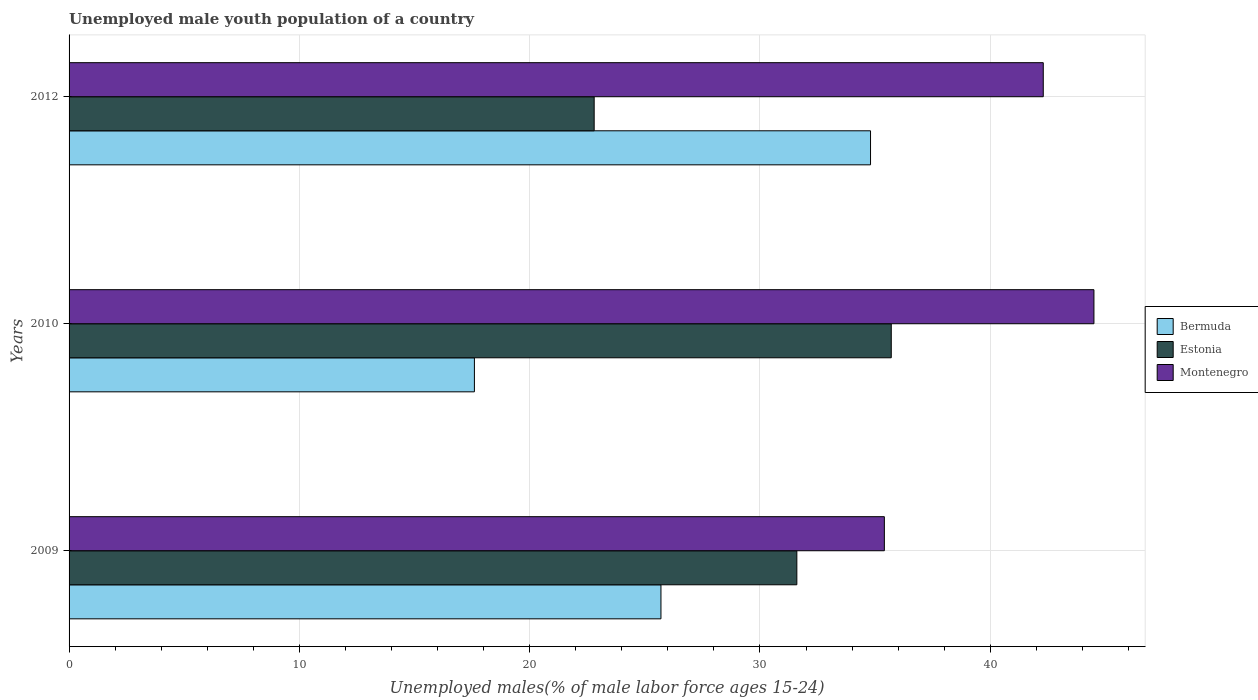How many different coloured bars are there?
Your answer should be very brief. 3. How many groups of bars are there?
Your response must be concise. 3. Are the number of bars per tick equal to the number of legend labels?
Make the answer very short. Yes. How many bars are there on the 2nd tick from the bottom?
Provide a short and direct response. 3. In how many cases, is the number of bars for a given year not equal to the number of legend labels?
Ensure brevity in your answer.  0. What is the percentage of unemployed male youth population in Montenegro in 2010?
Offer a terse response. 44.5. Across all years, what is the maximum percentage of unemployed male youth population in Estonia?
Provide a succinct answer. 35.7. Across all years, what is the minimum percentage of unemployed male youth population in Estonia?
Your response must be concise. 22.8. What is the total percentage of unemployed male youth population in Montenegro in the graph?
Make the answer very short. 122.2. What is the difference between the percentage of unemployed male youth population in Estonia in 2009 and that in 2010?
Keep it short and to the point. -4.1. What is the difference between the percentage of unemployed male youth population in Bermuda in 2010 and the percentage of unemployed male youth population in Estonia in 2009?
Your response must be concise. -14. What is the average percentage of unemployed male youth population in Estonia per year?
Your answer should be very brief. 30.03. In the year 2010, what is the difference between the percentage of unemployed male youth population in Bermuda and percentage of unemployed male youth population in Estonia?
Make the answer very short. -18.1. In how many years, is the percentage of unemployed male youth population in Estonia greater than 20 %?
Your answer should be compact. 3. What is the ratio of the percentage of unemployed male youth population in Montenegro in 2009 to that in 2010?
Your answer should be compact. 0.8. What is the difference between the highest and the second highest percentage of unemployed male youth population in Montenegro?
Make the answer very short. 2.2. What is the difference between the highest and the lowest percentage of unemployed male youth population in Estonia?
Provide a short and direct response. 12.9. In how many years, is the percentage of unemployed male youth population in Bermuda greater than the average percentage of unemployed male youth population in Bermuda taken over all years?
Your response must be concise. 1. What does the 3rd bar from the top in 2009 represents?
Your answer should be very brief. Bermuda. What does the 3rd bar from the bottom in 2012 represents?
Your answer should be very brief. Montenegro. Is it the case that in every year, the sum of the percentage of unemployed male youth population in Montenegro and percentage of unemployed male youth population in Estonia is greater than the percentage of unemployed male youth population in Bermuda?
Provide a short and direct response. Yes. Are all the bars in the graph horizontal?
Provide a succinct answer. Yes. How many years are there in the graph?
Your response must be concise. 3. What is the difference between two consecutive major ticks on the X-axis?
Keep it short and to the point. 10. Are the values on the major ticks of X-axis written in scientific E-notation?
Provide a short and direct response. No. Does the graph contain grids?
Offer a very short reply. Yes. How many legend labels are there?
Your answer should be compact. 3. What is the title of the graph?
Give a very brief answer. Unemployed male youth population of a country. Does "Niger" appear as one of the legend labels in the graph?
Your answer should be compact. No. What is the label or title of the X-axis?
Offer a terse response. Unemployed males(% of male labor force ages 15-24). What is the label or title of the Y-axis?
Provide a short and direct response. Years. What is the Unemployed males(% of male labor force ages 15-24) in Bermuda in 2009?
Your answer should be very brief. 25.7. What is the Unemployed males(% of male labor force ages 15-24) in Estonia in 2009?
Give a very brief answer. 31.6. What is the Unemployed males(% of male labor force ages 15-24) in Montenegro in 2009?
Offer a very short reply. 35.4. What is the Unemployed males(% of male labor force ages 15-24) in Bermuda in 2010?
Your response must be concise. 17.6. What is the Unemployed males(% of male labor force ages 15-24) in Estonia in 2010?
Offer a very short reply. 35.7. What is the Unemployed males(% of male labor force ages 15-24) of Montenegro in 2010?
Provide a succinct answer. 44.5. What is the Unemployed males(% of male labor force ages 15-24) of Bermuda in 2012?
Offer a very short reply. 34.8. What is the Unemployed males(% of male labor force ages 15-24) of Estonia in 2012?
Provide a short and direct response. 22.8. What is the Unemployed males(% of male labor force ages 15-24) of Montenegro in 2012?
Offer a terse response. 42.3. Across all years, what is the maximum Unemployed males(% of male labor force ages 15-24) of Bermuda?
Provide a short and direct response. 34.8. Across all years, what is the maximum Unemployed males(% of male labor force ages 15-24) of Estonia?
Ensure brevity in your answer.  35.7. Across all years, what is the maximum Unemployed males(% of male labor force ages 15-24) of Montenegro?
Ensure brevity in your answer.  44.5. Across all years, what is the minimum Unemployed males(% of male labor force ages 15-24) of Bermuda?
Provide a short and direct response. 17.6. Across all years, what is the minimum Unemployed males(% of male labor force ages 15-24) of Estonia?
Your answer should be compact. 22.8. Across all years, what is the minimum Unemployed males(% of male labor force ages 15-24) in Montenegro?
Make the answer very short. 35.4. What is the total Unemployed males(% of male labor force ages 15-24) of Bermuda in the graph?
Provide a succinct answer. 78.1. What is the total Unemployed males(% of male labor force ages 15-24) in Estonia in the graph?
Keep it short and to the point. 90.1. What is the total Unemployed males(% of male labor force ages 15-24) of Montenegro in the graph?
Give a very brief answer. 122.2. What is the difference between the Unemployed males(% of male labor force ages 15-24) in Bermuda in 2009 and that in 2010?
Keep it short and to the point. 8.1. What is the difference between the Unemployed males(% of male labor force ages 15-24) of Estonia in 2009 and that in 2012?
Provide a short and direct response. 8.8. What is the difference between the Unemployed males(% of male labor force ages 15-24) of Bermuda in 2010 and that in 2012?
Provide a short and direct response. -17.2. What is the difference between the Unemployed males(% of male labor force ages 15-24) of Montenegro in 2010 and that in 2012?
Your response must be concise. 2.2. What is the difference between the Unemployed males(% of male labor force ages 15-24) of Bermuda in 2009 and the Unemployed males(% of male labor force ages 15-24) of Montenegro in 2010?
Give a very brief answer. -18.8. What is the difference between the Unemployed males(% of male labor force ages 15-24) of Bermuda in 2009 and the Unemployed males(% of male labor force ages 15-24) of Estonia in 2012?
Give a very brief answer. 2.9. What is the difference between the Unemployed males(% of male labor force ages 15-24) in Bermuda in 2009 and the Unemployed males(% of male labor force ages 15-24) in Montenegro in 2012?
Keep it short and to the point. -16.6. What is the difference between the Unemployed males(% of male labor force ages 15-24) of Bermuda in 2010 and the Unemployed males(% of male labor force ages 15-24) of Montenegro in 2012?
Offer a very short reply. -24.7. What is the difference between the Unemployed males(% of male labor force ages 15-24) in Estonia in 2010 and the Unemployed males(% of male labor force ages 15-24) in Montenegro in 2012?
Your answer should be compact. -6.6. What is the average Unemployed males(% of male labor force ages 15-24) in Bermuda per year?
Your response must be concise. 26.03. What is the average Unemployed males(% of male labor force ages 15-24) of Estonia per year?
Offer a terse response. 30.03. What is the average Unemployed males(% of male labor force ages 15-24) in Montenegro per year?
Offer a very short reply. 40.73. In the year 2009, what is the difference between the Unemployed males(% of male labor force ages 15-24) in Bermuda and Unemployed males(% of male labor force ages 15-24) in Montenegro?
Ensure brevity in your answer.  -9.7. In the year 2010, what is the difference between the Unemployed males(% of male labor force ages 15-24) of Bermuda and Unemployed males(% of male labor force ages 15-24) of Estonia?
Your answer should be very brief. -18.1. In the year 2010, what is the difference between the Unemployed males(% of male labor force ages 15-24) in Bermuda and Unemployed males(% of male labor force ages 15-24) in Montenegro?
Provide a succinct answer. -26.9. In the year 2012, what is the difference between the Unemployed males(% of male labor force ages 15-24) of Estonia and Unemployed males(% of male labor force ages 15-24) of Montenegro?
Provide a short and direct response. -19.5. What is the ratio of the Unemployed males(% of male labor force ages 15-24) of Bermuda in 2009 to that in 2010?
Your answer should be compact. 1.46. What is the ratio of the Unemployed males(% of male labor force ages 15-24) of Estonia in 2009 to that in 2010?
Your answer should be compact. 0.89. What is the ratio of the Unemployed males(% of male labor force ages 15-24) in Montenegro in 2009 to that in 2010?
Keep it short and to the point. 0.8. What is the ratio of the Unemployed males(% of male labor force ages 15-24) in Bermuda in 2009 to that in 2012?
Provide a short and direct response. 0.74. What is the ratio of the Unemployed males(% of male labor force ages 15-24) in Estonia in 2009 to that in 2012?
Give a very brief answer. 1.39. What is the ratio of the Unemployed males(% of male labor force ages 15-24) in Montenegro in 2009 to that in 2012?
Your answer should be compact. 0.84. What is the ratio of the Unemployed males(% of male labor force ages 15-24) of Bermuda in 2010 to that in 2012?
Make the answer very short. 0.51. What is the ratio of the Unemployed males(% of male labor force ages 15-24) in Estonia in 2010 to that in 2012?
Provide a short and direct response. 1.57. What is the ratio of the Unemployed males(% of male labor force ages 15-24) of Montenegro in 2010 to that in 2012?
Ensure brevity in your answer.  1.05. What is the difference between the highest and the second highest Unemployed males(% of male labor force ages 15-24) of Bermuda?
Give a very brief answer. 9.1. What is the difference between the highest and the second highest Unemployed males(% of male labor force ages 15-24) of Estonia?
Keep it short and to the point. 4.1. 